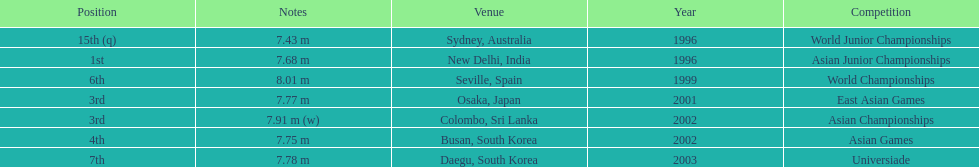What is the number of competitions that have been competed in? 7. 